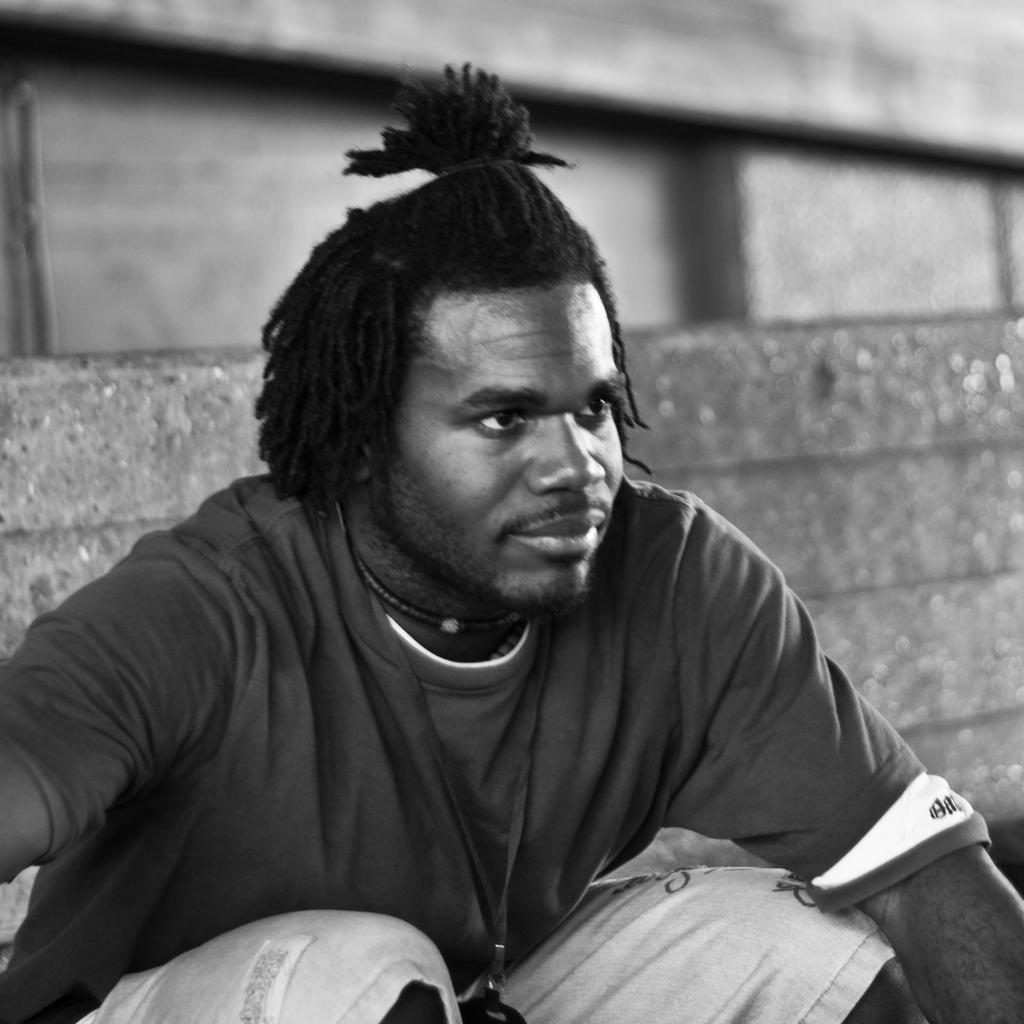What is the main subject of the image? There is a man in the image. What is the color scheme of the image? The image is black and white. How many hands does the man have in the image? The number of hands cannot be determined from the image, as it is black and white and may not show details like hands. 